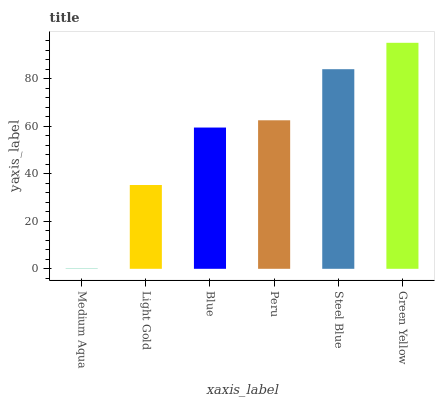Is Medium Aqua the minimum?
Answer yes or no. Yes. Is Green Yellow the maximum?
Answer yes or no. Yes. Is Light Gold the minimum?
Answer yes or no. No. Is Light Gold the maximum?
Answer yes or no. No. Is Light Gold greater than Medium Aqua?
Answer yes or no. Yes. Is Medium Aqua less than Light Gold?
Answer yes or no. Yes. Is Medium Aqua greater than Light Gold?
Answer yes or no. No. Is Light Gold less than Medium Aqua?
Answer yes or no. No. Is Peru the high median?
Answer yes or no. Yes. Is Blue the low median?
Answer yes or no. Yes. Is Medium Aqua the high median?
Answer yes or no. No. Is Steel Blue the low median?
Answer yes or no. No. 